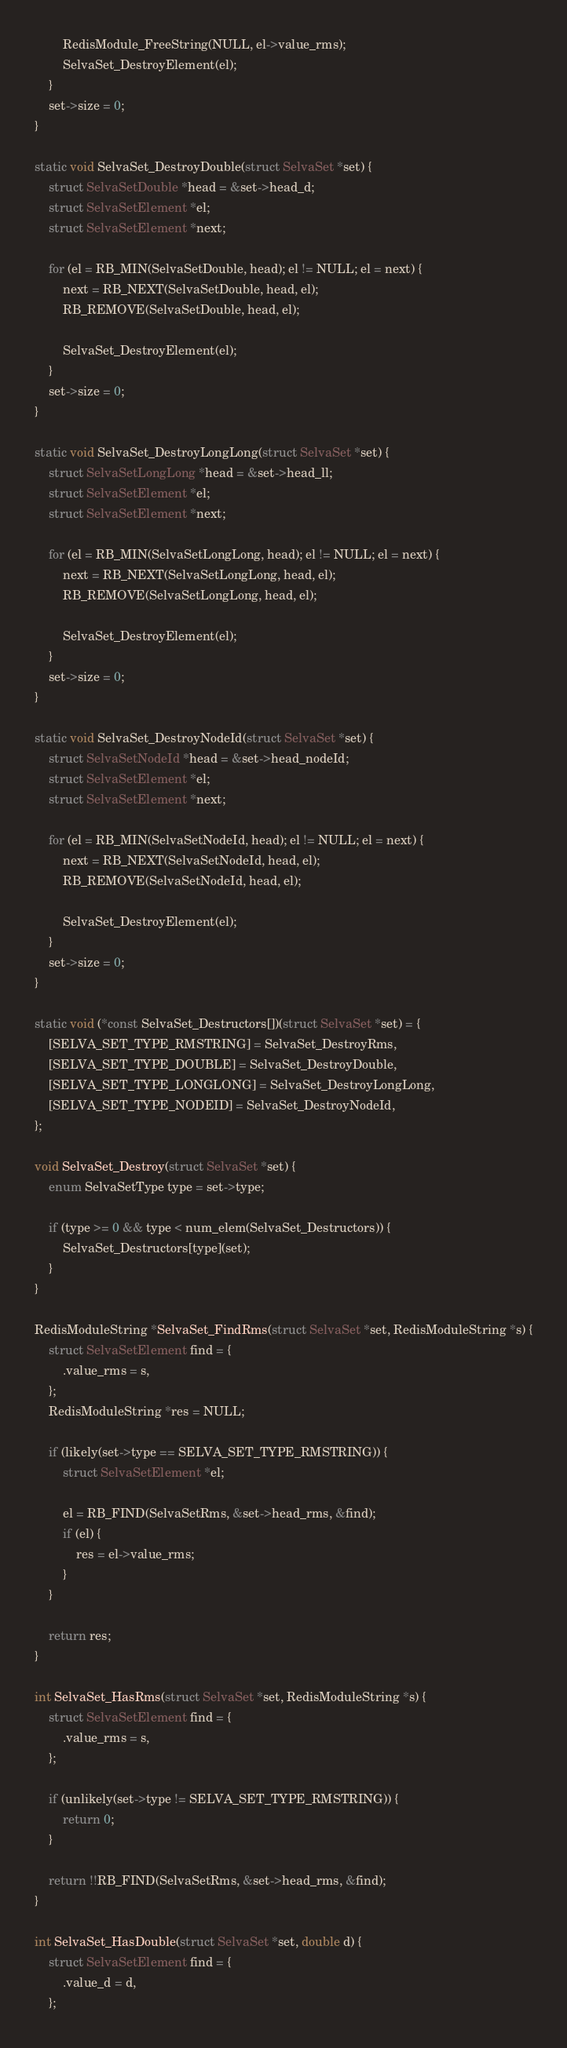<code> <loc_0><loc_0><loc_500><loc_500><_C_>        RedisModule_FreeString(NULL, el->value_rms);
        SelvaSet_DestroyElement(el);
    }
    set->size = 0;
}

static void SelvaSet_DestroyDouble(struct SelvaSet *set) {
    struct SelvaSetDouble *head = &set->head_d;
    struct SelvaSetElement *el;
    struct SelvaSetElement *next;

    for (el = RB_MIN(SelvaSetDouble, head); el != NULL; el = next) {
        next = RB_NEXT(SelvaSetDouble, head, el);
        RB_REMOVE(SelvaSetDouble, head, el);

        SelvaSet_DestroyElement(el);
    }
    set->size = 0;
}

static void SelvaSet_DestroyLongLong(struct SelvaSet *set) {
    struct SelvaSetLongLong *head = &set->head_ll;
    struct SelvaSetElement *el;
    struct SelvaSetElement *next;

    for (el = RB_MIN(SelvaSetLongLong, head); el != NULL; el = next) {
        next = RB_NEXT(SelvaSetLongLong, head, el);
        RB_REMOVE(SelvaSetLongLong, head, el);

        SelvaSet_DestroyElement(el);
    }
    set->size = 0;
}

static void SelvaSet_DestroyNodeId(struct SelvaSet *set) {
    struct SelvaSetNodeId *head = &set->head_nodeId;
    struct SelvaSetElement *el;
    struct SelvaSetElement *next;

    for (el = RB_MIN(SelvaSetNodeId, head); el != NULL; el = next) {
        next = RB_NEXT(SelvaSetNodeId, head, el);
        RB_REMOVE(SelvaSetNodeId, head, el);

        SelvaSet_DestroyElement(el);
    }
    set->size = 0;
}

static void (*const SelvaSet_Destructors[])(struct SelvaSet *set) = {
    [SELVA_SET_TYPE_RMSTRING] = SelvaSet_DestroyRms,
    [SELVA_SET_TYPE_DOUBLE] = SelvaSet_DestroyDouble,
    [SELVA_SET_TYPE_LONGLONG] = SelvaSet_DestroyLongLong,
    [SELVA_SET_TYPE_NODEID] = SelvaSet_DestroyNodeId,
};

void SelvaSet_Destroy(struct SelvaSet *set) {
    enum SelvaSetType type = set->type;

    if (type >= 0 && type < num_elem(SelvaSet_Destructors)) {
        SelvaSet_Destructors[type](set);
    }
}

RedisModuleString *SelvaSet_FindRms(struct SelvaSet *set, RedisModuleString *s) {
    struct SelvaSetElement find = {
        .value_rms = s,
    };
    RedisModuleString *res = NULL;

    if (likely(set->type == SELVA_SET_TYPE_RMSTRING)) {
        struct SelvaSetElement *el;

        el = RB_FIND(SelvaSetRms, &set->head_rms, &find);
        if (el) {
            res = el->value_rms;
        }
    }

    return res;
}

int SelvaSet_HasRms(struct SelvaSet *set, RedisModuleString *s) {
    struct SelvaSetElement find = {
        .value_rms = s,
    };

    if (unlikely(set->type != SELVA_SET_TYPE_RMSTRING)) {
        return 0;
    }

    return !!RB_FIND(SelvaSetRms, &set->head_rms, &find);
}

int SelvaSet_HasDouble(struct SelvaSet *set, double d) {
    struct SelvaSetElement find = {
        .value_d = d,
    };
</code> 